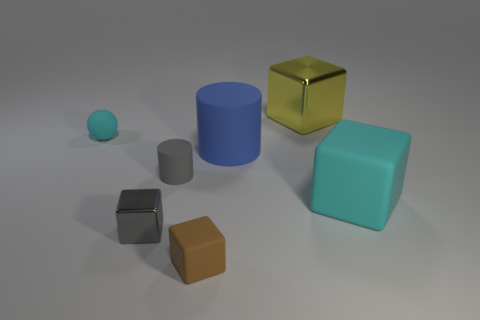Is the number of gray metallic blocks that are behind the gray cylinder less than the number of tiny rubber blocks in front of the small shiny block?
Your answer should be compact. Yes. There is a sphere; is its size the same as the rubber block that is on the right side of the tiny brown cube?
Your answer should be very brief. No. What number of cyan metal cubes have the same size as the gray block?
Your response must be concise. 0. The other cube that is the same material as the tiny gray block is what color?
Offer a terse response. Yellow. Are there more metallic cubes than blocks?
Ensure brevity in your answer.  No. Does the blue cylinder have the same material as the big cyan cube?
Provide a succinct answer. Yes. There is a small gray object that is the same material as the large blue object; what shape is it?
Keep it short and to the point. Cylinder. Is the number of brown matte cubes less than the number of yellow matte balls?
Provide a succinct answer. No. The cube that is both left of the big shiny object and right of the small gray rubber object is made of what material?
Make the answer very short. Rubber. How big is the metal cube to the left of the large shiny block that is on the right side of the matte cylinder in front of the blue matte cylinder?
Provide a succinct answer. Small. 